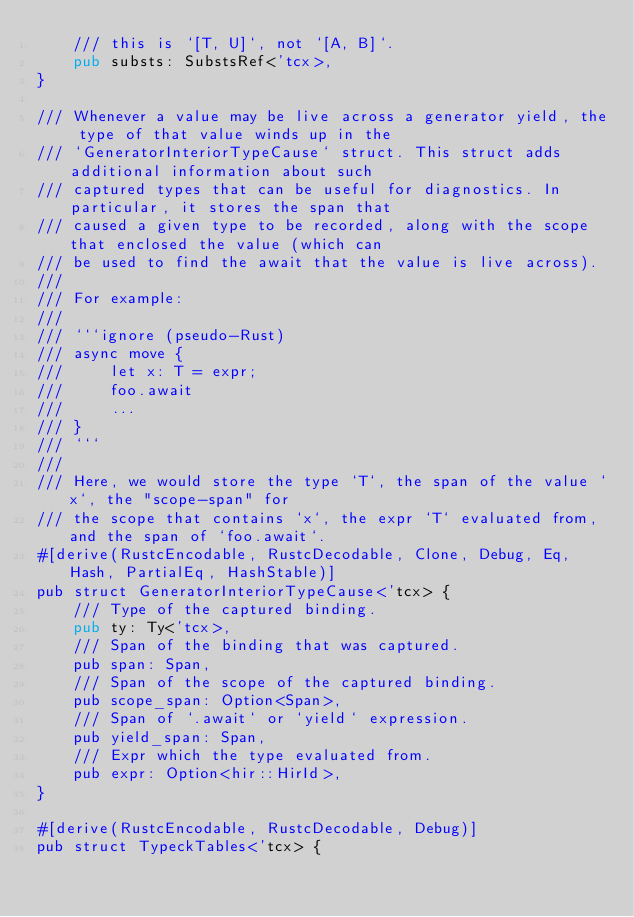<code> <loc_0><loc_0><loc_500><loc_500><_Rust_>    /// this is `[T, U]`, not `[A, B]`.
    pub substs: SubstsRef<'tcx>,
}

/// Whenever a value may be live across a generator yield, the type of that value winds up in the
/// `GeneratorInteriorTypeCause` struct. This struct adds additional information about such
/// captured types that can be useful for diagnostics. In particular, it stores the span that
/// caused a given type to be recorded, along with the scope that enclosed the value (which can
/// be used to find the await that the value is live across).
///
/// For example:
///
/// ```ignore (pseudo-Rust)
/// async move {
///     let x: T = expr;
///     foo.await
///     ...
/// }
/// ```
///
/// Here, we would store the type `T`, the span of the value `x`, the "scope-span" for
/// the scope that contains `x`, the expr `T` evaluated from, and the span of `foo.await`.
#[derive(RustcEncodable, RustcDecodable, Clone, Debug, Eq, Hash, PartialEq, HashStable)]
pub struct GeneratorInteriorTypeCause<'tcx> {
    /// Type of the captured binding.
    pub ty: Ty<'tcx>,
    /// Span of the binding that was captured.
    pub span: Span,
    /// Span of the scope of the captured binding.
    pub scope_span: Option<Span>,
    /// Span of `.await` or `yield` expression.
    pub yield_span: Span,
    /// Expr which the type evaluated from.
    pub expr: Option<hir::HirId>,
}

#[derive(RustcEncodable, RustcDecodable, Debug)]
pub struct TypeckTables<'tcx> {</code> 